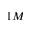<formula> <loc_0><loc_0><loc_500><loc_500>1 M</formula> 